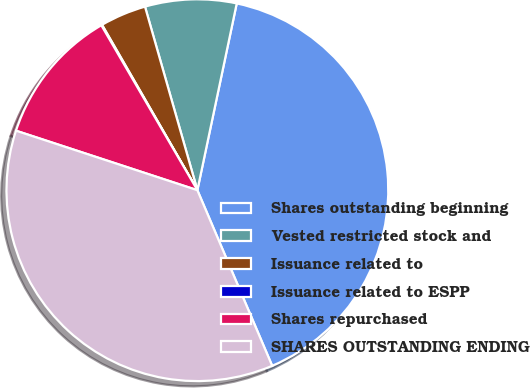<chart> <loc_0><loc_0><loc_500><loc_500><pie_chart><fcel>Shares outstanding beginning<fcel>Vested restricted stock and<fcel>Issuance related to<fcel>Issuance related to ESPP<fcel>Shares repurchased<fcel>SHARES OUTSTANDING ENDING<nl><fcel>40.28%<fcel>7.73%<fcel>3.9%<fcel>0.07%<fcel>11.56%<fcel>36.45%<nl></chart> 